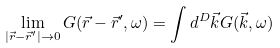<formula> <loc_0><loc_0><loc_500><loc_500>\lim _ { | { \vec { r } } - { \vec { r } } ^ { \prime } | \rightarrow 0 } G ( { \vec { r } } - { \vec { r } } ^ { \prime } , \omega ) = \int d ^ { D } { \vec { k } } G ( { \vec { k } } , \omega )</formula> 